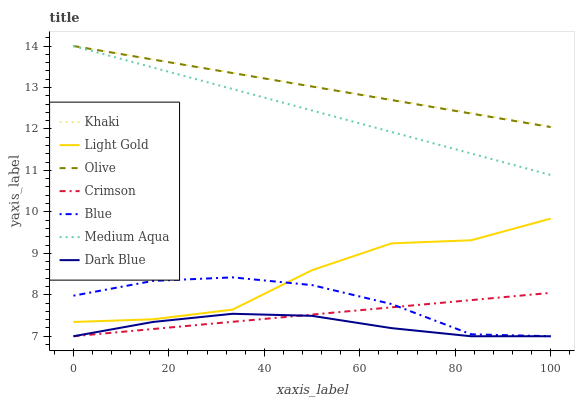Does Dark Blue have the minimum area under the curve?
Answer yes or no. Yes. Does Khaki have the maximum area under the curve?
Answer yes or no. Yes. Does Khaki have the minimum area under the curve?
Answer yes or no. No. Does Dark Blue have the maximum area under the curve?
Answer yes or no. No. Is Crimson the smoothest?
Answer yes or no. Yes. Is Light Gold the roughest?
Answer yes or no. Yes. Is Khaki the smoothest?
Answer yes or no. No. Is Khaki the roughest?
Answer yes or no. No. Does Blue have the lowest value?
Answer yes or no. Yes. Does Khaki have the lowest value?
Answer yes or no. No. Does Olive have the highest value?
Answer yes or no. Yes. Does Dark Blue have the highest value?
Answer yes or no. No. Is Light Gold less than Medium Aqua?
Answer yes or no. Yes. Is Khaki greater than Light Gold?
Answer yes or no. Yes. Does Blue intersect Crimson?
Answer yes or no. Yes. Is Blue less than Crimson?
Answer yes or no. No. Is Blue greater than Crimson?
Answer yes or no. No. Does Light Gold intersect Medium Aqua?
Answer yes or no. No. 